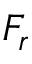<formula> <loc_0><loc_0><loc_500><loc_500>F _ { r }</formula> 